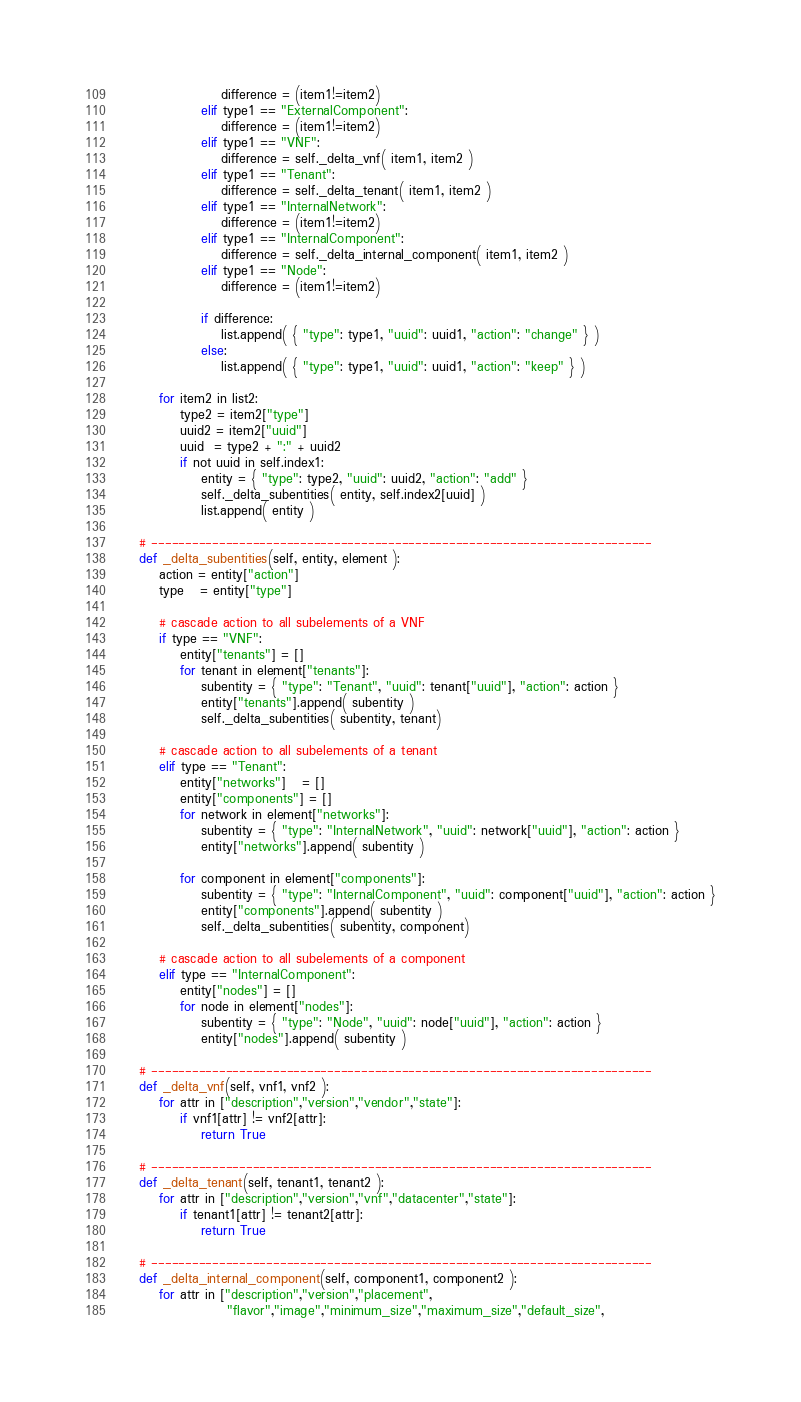Convert code to text. <code><loc_0><loc_0><loc_500><loc_500><_Python_>                    difference = (item1!=item2)
                elif type1 == "ExternalComponent":
                    difference = (item1!=item2)
                elif type1 == "VNF":
                    difference = self._delta_vnf( item1, item2 )
                elif type1 == "Tenant":
                    difference = self._delta_tenant( item1, item2 )
                elif type1 == "InternalNetwork":
                    difference = (item1!=item2)
                elif type1 == "InternalComponent":
                    difference = self._delta_internal_component( item1, item2 )
                elif type1 == "Node":
                    difference = (item1!=item2)

                if difference:
                    list.append( { "type": type1, "uuid": uuid1, "action": "change" } )
                else:
                    list.append( { "type": type1, "uuid": uuid1, "action": "keep" } )

        for item2 in list2:
            type2 = item2["type"]
            uuid2 = item2["uuid"]
            uuid  = type2 + ":" + uuid2
            if not uuid in self.index1:
                entity = { "type": type2, "uuid": uuid2, "action": "add" }
                self._delta_subentities( entity, self.index2[uuid] )
                list.append( entity )

    # --------------------------------------------------------------------------
    def _delta_subentities(self, entity, element ):
        action = entity["action"]
        type   = entity["type"]

        # cascade action to all subelements of a VNF
        if type == "VNF":
            entity["tenants"] = []
            for tenant in element["tenants"]:
                subentity = { "type": "Tenant", "uuid": tenant["uuid"], "action": action }
                entity["tenants"].append( subentity )
                self._delta_subentities( subentity, tenant)

        # cascade action to all subelements of a tenant
        elif type == "Tenant":
            entity["networks"]   = []
            entity["components"] = []
            for network in element["networks"]:
                subentity = { "type": "InternalNetwork", "uuid": network["uuid"], "action": action }
                entity["networks"].append( subentity )

            for component in element["components"]:
                subentity = { "type": "InternalComponent", "uuid": component["uuid"], "action": action }
                entity["components"].append( subentity )
                self._delta_subentities( subentity, component)

        # cascade action to all subelements of a component
        elif type == "InternalComponent":
            entity["nodes"] = []
            for node in element["nodes"]:
                subentity = { "type": "Node", "uuid": node["uuid"], "action": action }
                entity["nodes"].append( subentity )

    # --------------------------------------------------------------------------
    def _delta_vnf(self, vnf1, vnf2 ):
        for attr in ["description","version","vendor","state"]:
            if vnf1[attr] != vnf2[attr]:
                return True

    # --------------------------------------------------------------------------
    def _delta_tenant(self, tenant1, tenant2 ):
        for attr in ["description","version","vnf","datacenter","state"]:
            if tenant1[attr] != tenant2[attr]:
                return True

    # --------------------------------------------------------------------------
    def _delta_internal_component(self, component1, component2 ):
        for attr in ["description","version","placement",
                     "flavor","image","minimum_size","maximum_size","default_size",</code> 